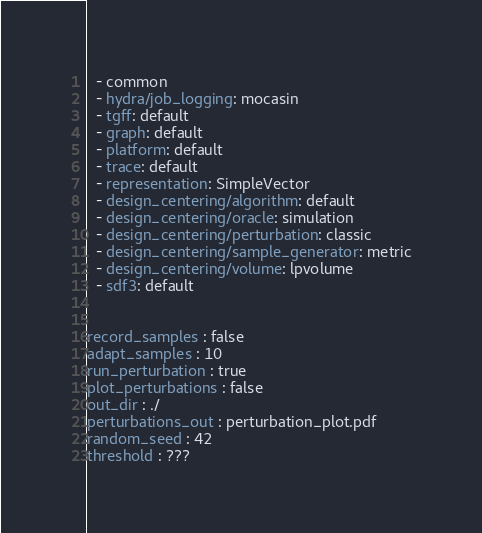<code> <loc_0><loc_0><loc_500><loc_500><_YAML_>  - common
  - hydra/job_logging: mocasin
  - tgff: default
  - graph: default
  - platform: default
  - trace: default
  - representation: SimpleVector
  - design_centering/algorithm: default
  - design_centering/oracle: simulation
  - design_centering/perturbation: classic
  - design_centering/sample_generator: metric
  - design_centering/volume: lpvolume
  - sdf3: default


record_samples : false
adapt_samples : 10
run_perturbation : true
plot_perturbations : false
out_dir : ./
perturbations_out : perturbation_plot.pdf
random_seed : 42
threshold : ???

</code> 